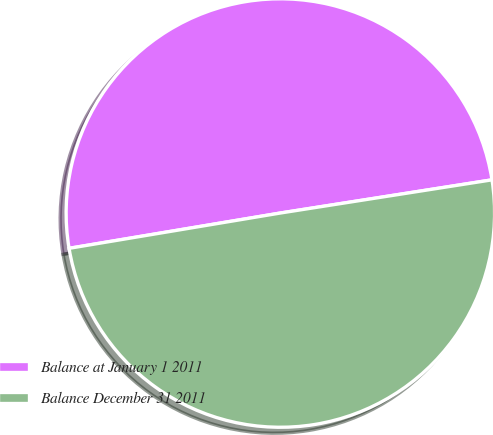Convert chart to OTSL. <chart><loc_0><loc_0><loc_500><loc_500><pie_chart><fcel>Balance at January 1 2011<fcel>Balance December 31 2011<nl><fcel>50.16%<fcel>49.84%<nl></chart> 